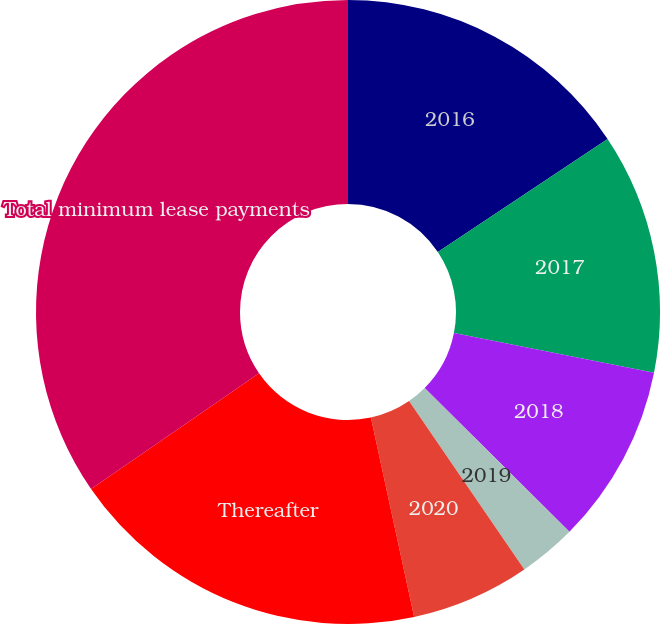<chart> <loc_0><loc_0><loc_500><loc_500><pie_chart><fcel>2016<fcel>2017<fcel>2018<fcel>2019<fcel>2020<fcel>Thereafter<fcel>Total minimum lease payments<nl><fcel>15.64%<fcel>12.48%<fcel>9.32%<fcel>3.0%<fcel>6.16%<fcel>18.8%<fcel>34.6%<nl></chart> 